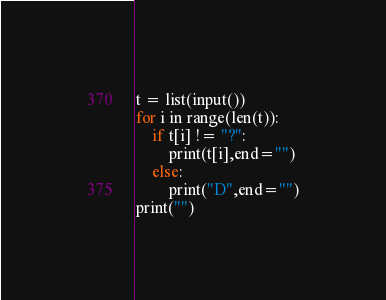Convert code to text. <code><loc_0><loc_0><loc_500><loc_500><_Python_>t = list(input())
for i in range(len(t)):
    if t[i] != "?":
        print(t[i],end="")
    else:
        print("D",end="")
print("")</code> 